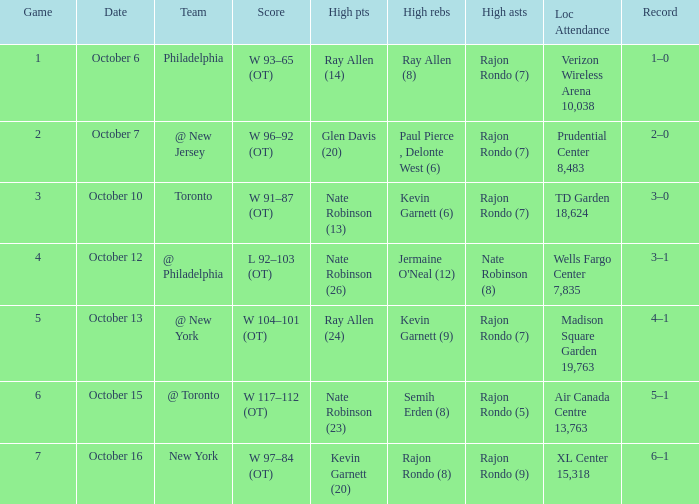Who had the most assists and how many did they have on October 7?  Rajon Rondo (7). 